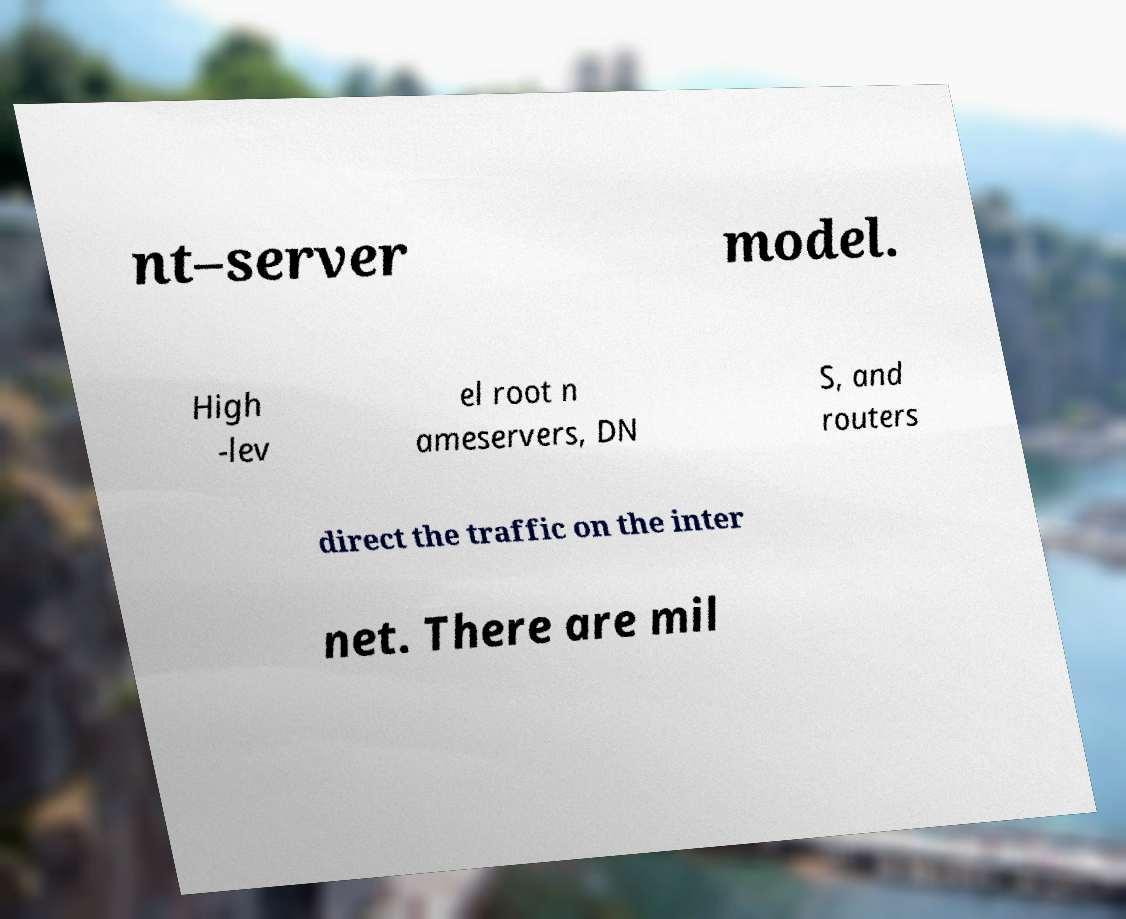For documentation purposes, I need the text within this image transcribed. Could you provide that? nt–server model. High -lev el root n ameservers, DN S, and routers direct the traffic on the inter net. There are mil 